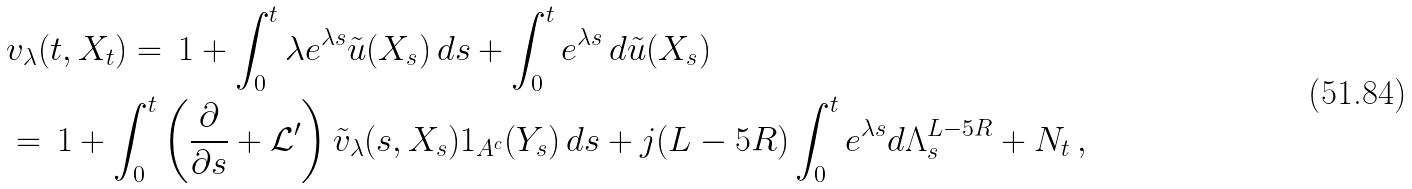Convert formula to latex. <formula><loc_0><loc_0><loc_500><loc_500>& v _ { \lambda } ( t , X _ { t } ) = \, 1 + \int _ { 0 } ^ { t } \lambda e ^ { \lambda s } \tilde { u } ( X _ { s } ) \, d s + \int _ { 0 } ^ { t } e ^ { \lambda s } \, d \tilde { u } ( X _ { s } ) \\ & = \, 1 + \int _ { 0 } ^ { t } \left ( \frac { \partial } { \partial s } + \mathcal { L } ^ { \prime } \right ) \tilde { v } _ { \lambda } ( s , X _ { s } ) { 1 } _ { A ^ { c } } ( Y _ { s } ) \, d s + j ( L - 5 R ) \int _ { 0 } ^ { t } e ^ { \lambda s } d \Lambda ^ { L - 5 R } _ { s } + N _ { t } \, ,</formula> 